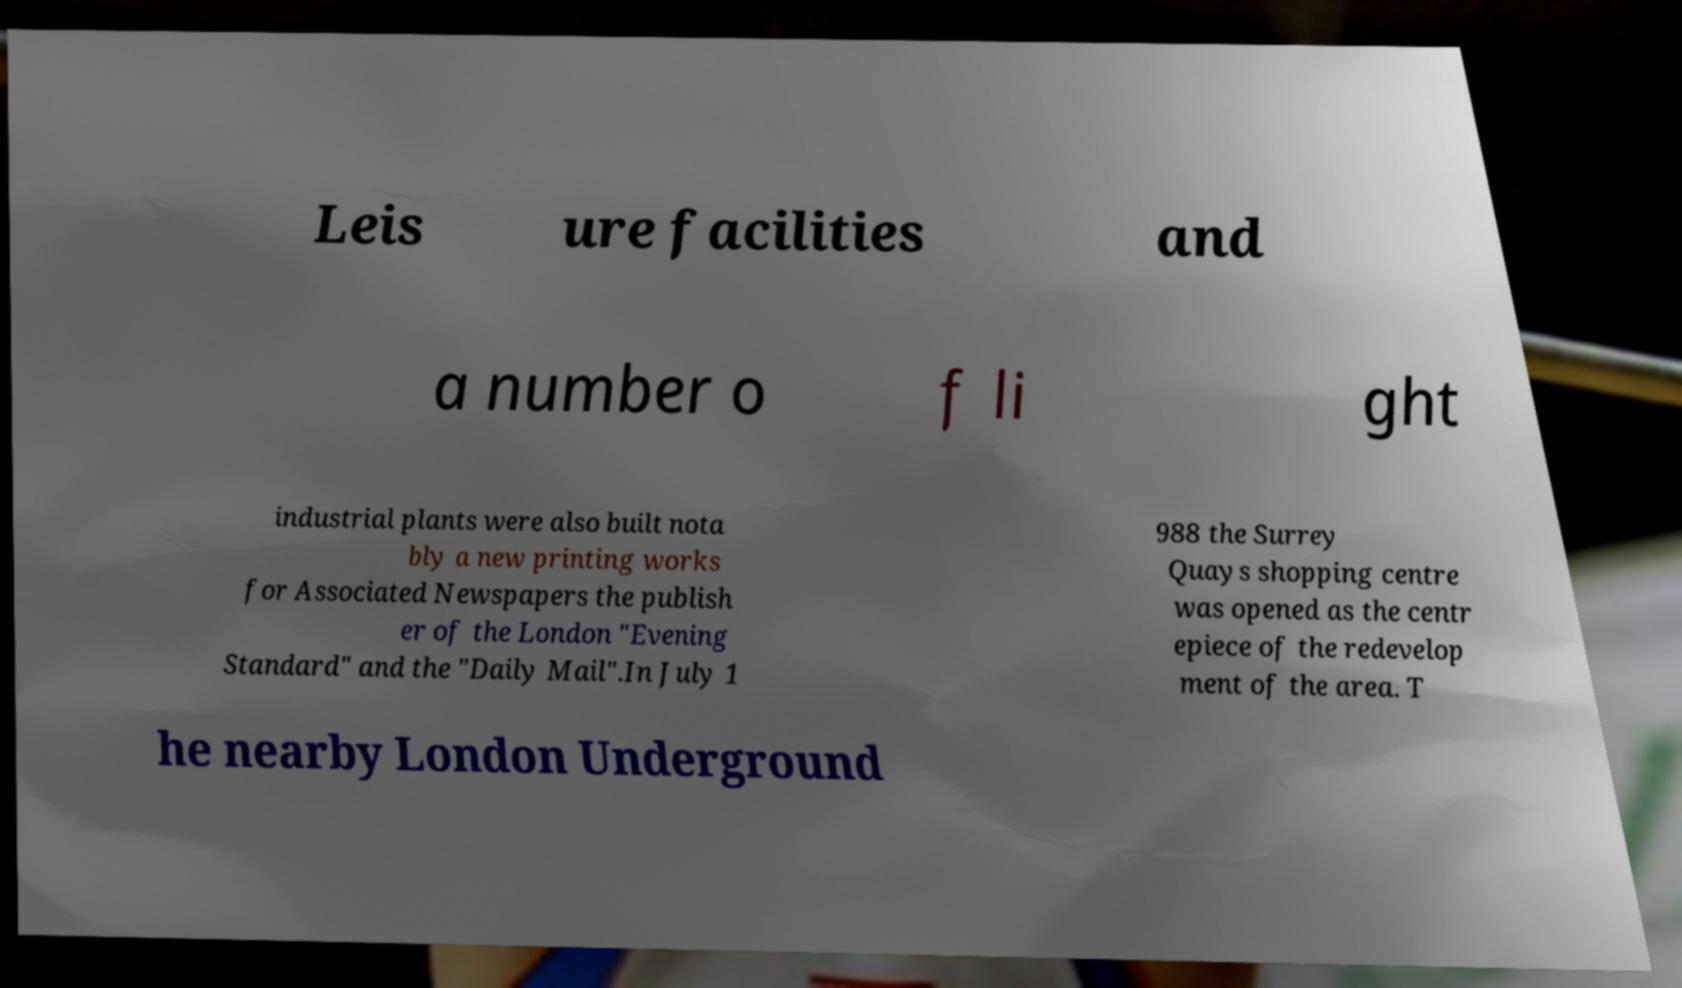What messages or text are displayed in this image? I need them in a readable, typed format. Leis ure facilities and a number o f li ght industrial plants were also built nota bly a new printing works for Associated Newspapers the publish er of the London "Evening Standard" and the "Daily Mail".In July 1 988 the Surrey Quays shopping centre was opened as the centr epiece of the redevelop ment of the area. T he nearby London Underground 